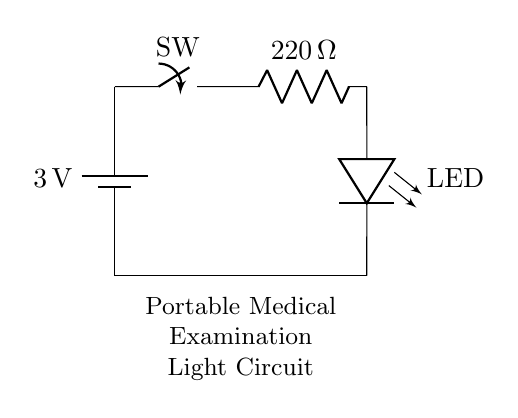What type of switch is used in this circuit? The circuit diagram does not specify the type of switch in detail; however, it represents a simple on-off switch, which is indicated by the symbol used.
Answer: Switch What is the resistance value in the circuit? The resistor connected in the circuit is labeled as having a resistance of 220 Ohms, which is an essential component for controlling current to the LED.
Answer: 220 Ohms What is the purpose of the resistor in this circuit? The resistor limits the current flowing to the LED to prevent it from burning out due to excessive current, maintaining safe operation within its specifications.
Answer: Current limiter What is the total voltage supplied by the battery? The battery in the circuit diagram is labeled with a voltage of 3 volts, which is the total potential difference supplied to the circuit.
Answer: 3 volts What happens when the switch is closed? Closing the switch completes the circuit, allowing current to flow from the battery through the resistor to the LED, thus illuminating the LED.
Answer: LED lights up What is the type of LED used in this circuit? The circuit does not specify the exact type of LED, but it implies the use of a standard low-power LED suitable for portable lighting applications in medical examinations.
Answer: Low-power LED Why is this circuit considered low power? The circuit operates on a low voltage of 3 volts and uses components like a 220 Ohm resistor and an LED, which together consume little power, making it suitable for battery-operated applications.
Answer: Low voltage operation 